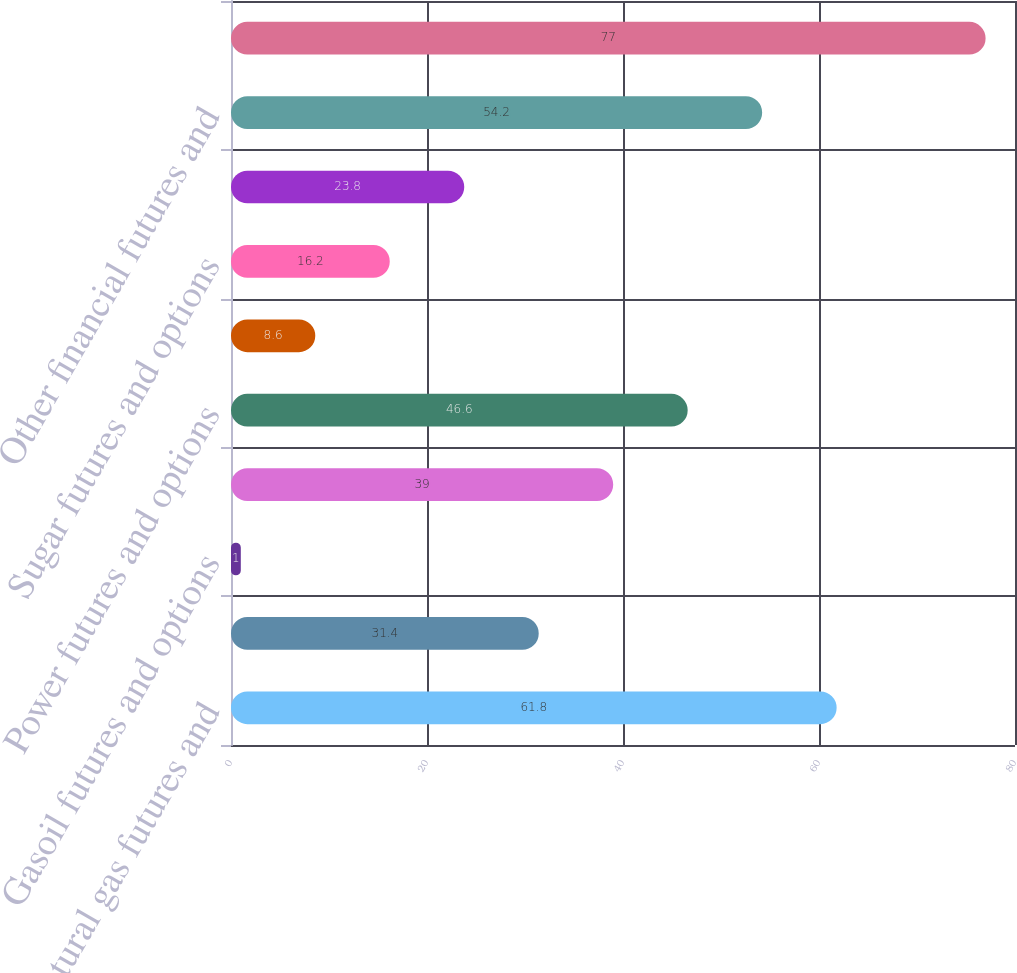Convert chart. <chart><loc_0><loc_0><loc_500><loc_500><bar_chart><fcel>Natural gas futures and<fcel>Brent crude futures and<fcel>Gasoil futures and options<fcel>Other oil futures and options<fcel>Power futures and options<fcel>Emissions and other energy<fcel>Sugar futures and options<fcel>Other agricultural and metals<fcel>Other financial futures and<fcel>Total<nl><fcel>61.8<fcel>31.4<fcel>1<fcel>39<fcel>46.6<fcel>8.6<fcel>16.2<fcel>23.8<fcel>54.2<fcel>77<nl></chart> 